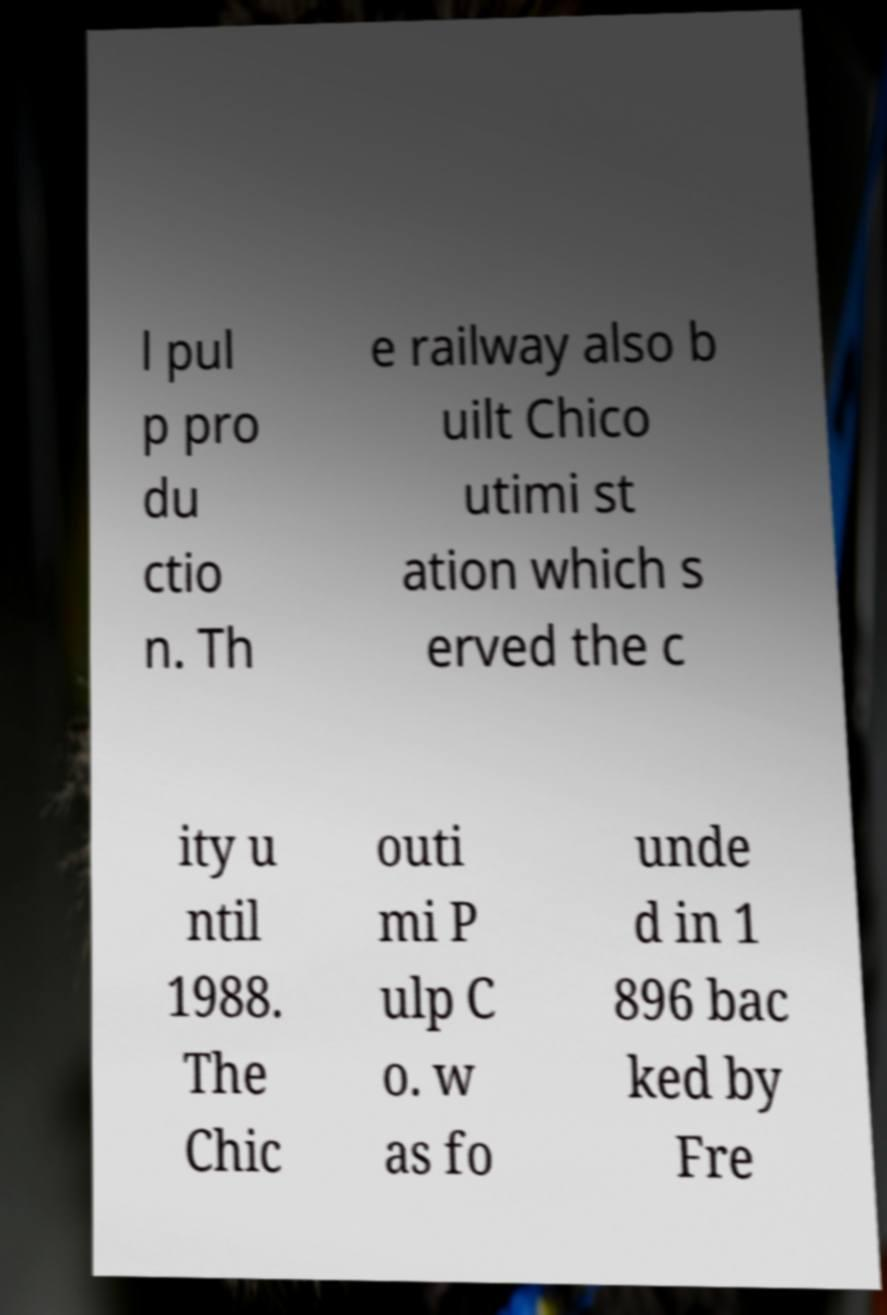What messages or text are displayed in this image? I need them in a readable, typed format. l pul p pro du ctio n. Th e railway also b uilt Chico utimi st ation which s erved the c ity u ntil 1988. The Chic outi mi P ulp C o. w as fo unde d in 1 896 bac ked by Fre 